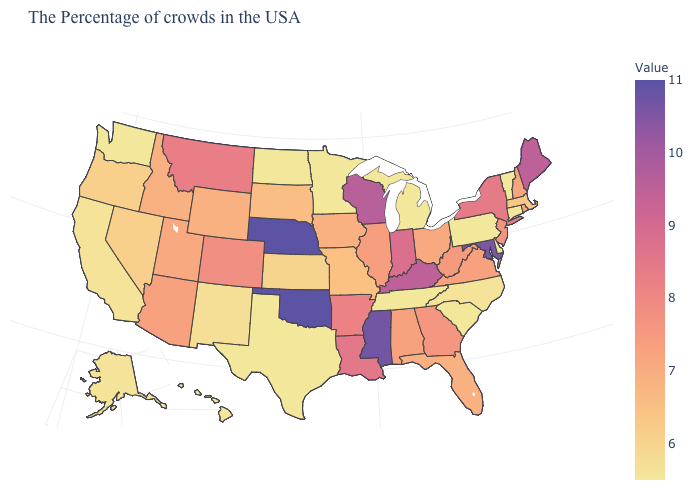Is the legend a continuous bar?
Concise answer only. Yes. Does Nevada have the highest value in the West?
Concise answer only. No. Does the map have missing data?
Quick response, please. No. Does Rhode Island have the lowest value in the Northeast?
Concise answer only. No. Does Connecticut have the lowest value in the Northeast?
Short answer required. Yes. 